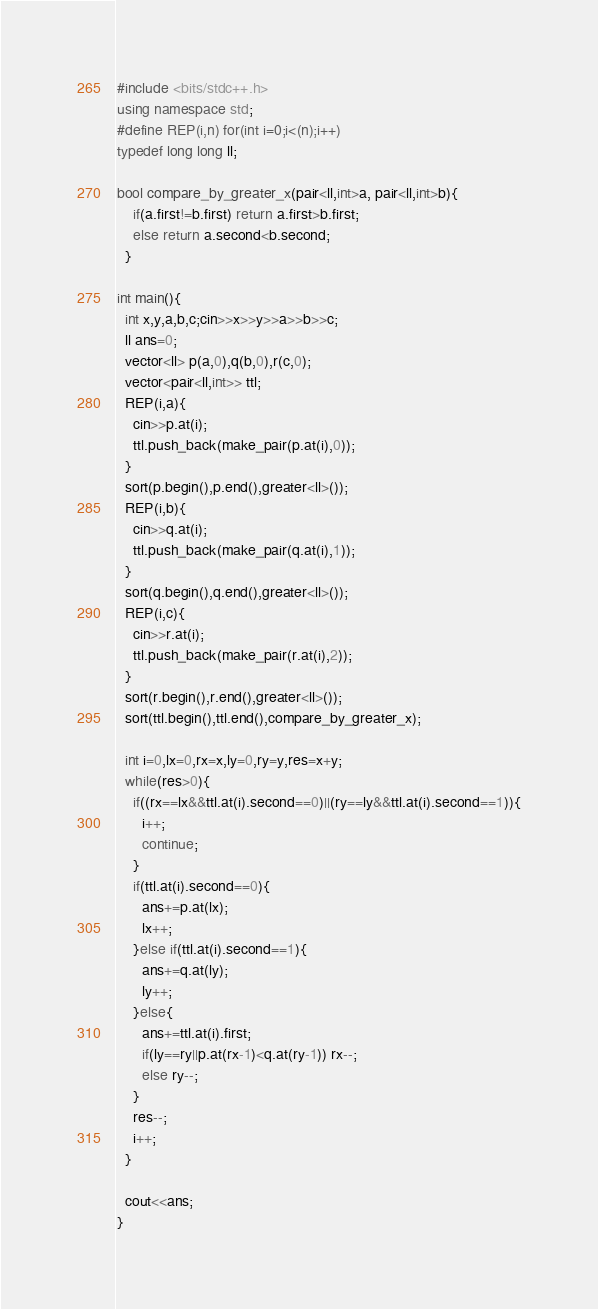Convert code to text. <code><loc_0><loc_0><loc_500><loc_500><_C++_>#include <bits/stdc++.h>
using namespace std;
#define REP(i,n) for(int i=0;i<(n);i++)
typedef long long ll;

bool compare_by_greater_x(pair<ll,int>a, pair<ll,int>b){
    if(a.first!=b.first) return a.first>b.first;
    else return a.second<b.second;
  }

int main(){
  int x,y,a,b,c;cin>>x>>y>>a>>b>>c;
  ll ans=0;
  vector<ll> p(a,0),q(b,0),r(c,0);
  vector<pair<ll,int>> ttl;
  REP(i,a){
    cin>>p.at(i);
    ttl.push_back(make_pair(p.at(i),0));
  }
  sort(p.begin(),p.end(),greater<ll>());
  REP(i,b){
    cin>>q.at(i);
    ttl.push_back(make_pair(q.at(i),1));
  }
  sort(q.begin(),q.end(),greater<ll>());
  REP(i,c){
    cin>>r.at(i);
    ttl.push_back(make_pair(r.at(i),2));
  }
  sort(r.begin(),r.end(),greater<ll>());
  sort(ttl.begin(),ttl.end(),compare_by_greater_x);

  int i=0,lx=0,rx=x,ly=0,ry=y,res=x+y;
  while(res>0){
    if((rx==lx&&ttl.at(i).second==0)||(ry==ly&&ttl.at(i).second==1)){
      i++;
      continue;
    }
    if(ttl.at(i).second==0){
      ans+=p.at(lx);
      lx++;
    }else if(ttl.at(i).second==1){
      ans+=q.at(ly);
      ly++;
    }else{
      ans+=ttl.at(i).first;
      if(ly==ry||p.at(rx-1)<q.at(ry-1)) rx--;
      else ry--;
    }
    res--;
    i++;
  }

  cout<<ans;
}</code> 